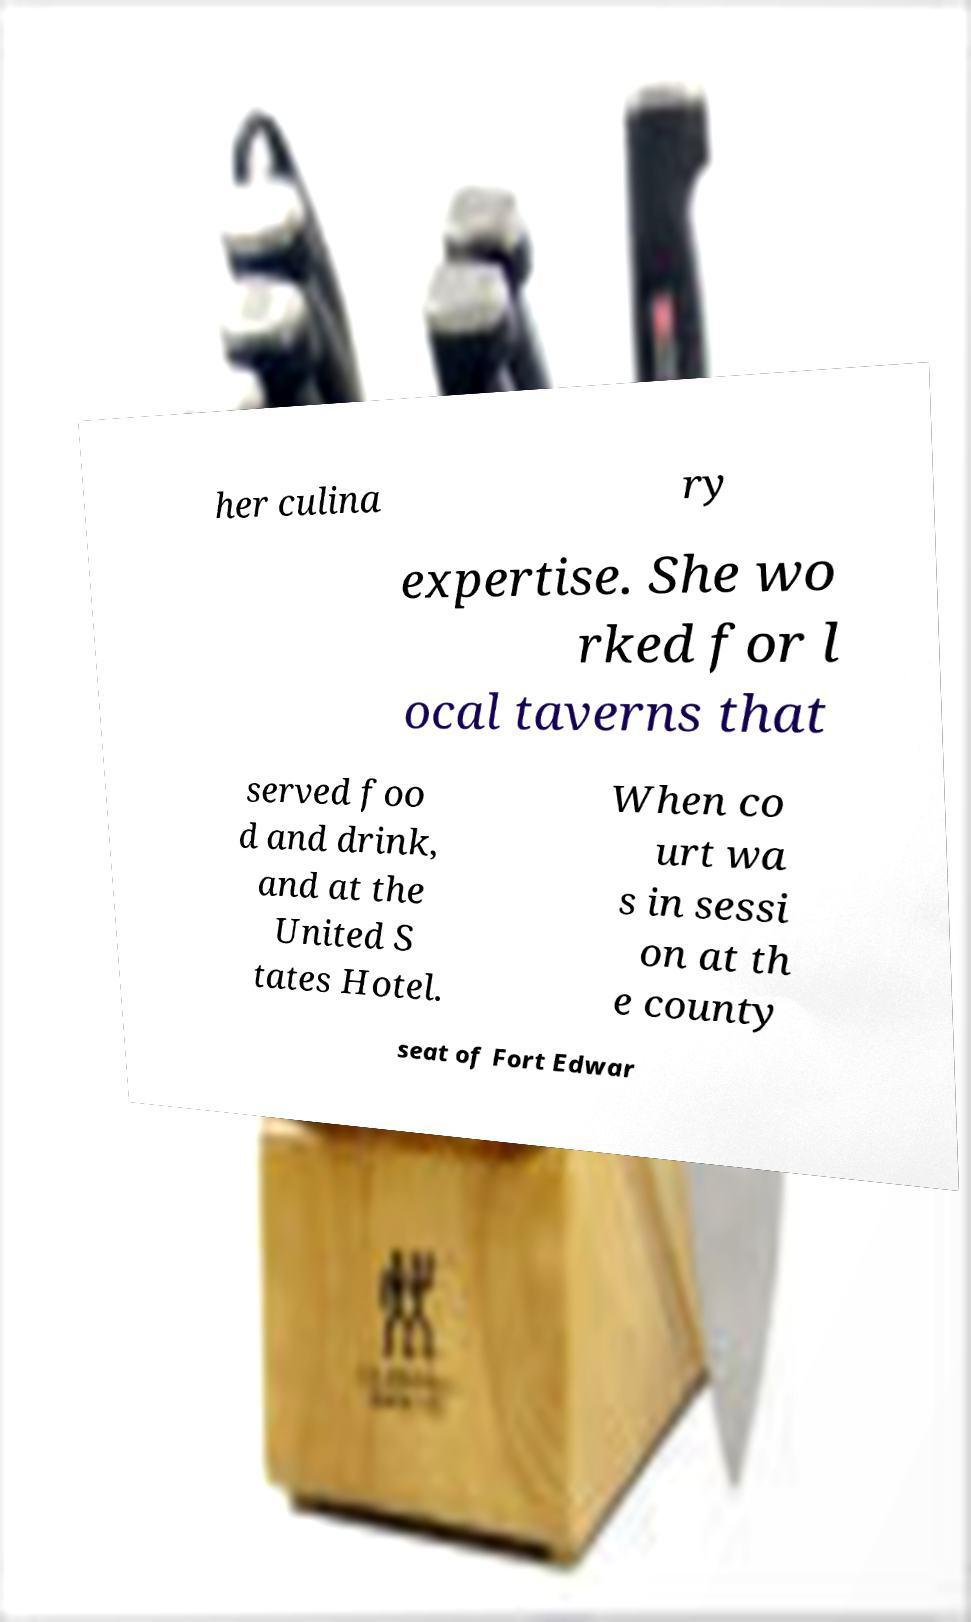There's text embedded in this image that I need extracted. Can you transcribe it verbatim? her culina ry expertise. She wo rked for l ocal taverns that served foo d and drink, and at the United S tates Hotel. When co urt wa s in sessi on at th e county seat of Fort Edwar 